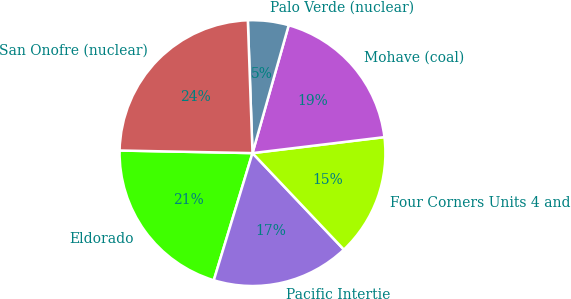<chart> <loc_0><loc_0><loc_500><loc_500><pie_chart><fcel>Eldorado<fcel>Pacific Intertie<fcel>Four Corners Units 4 and<fcel>Mohave (coal)<fcel>Palo Verde (nuclear)<fcel>San Onofre (nuclear)<nl><fcel>20.61%<fcel>16.77%<fcel>14.85%<fcel>18.69%<fcel>4.95%<fcel>24.13%<nl></chart> 